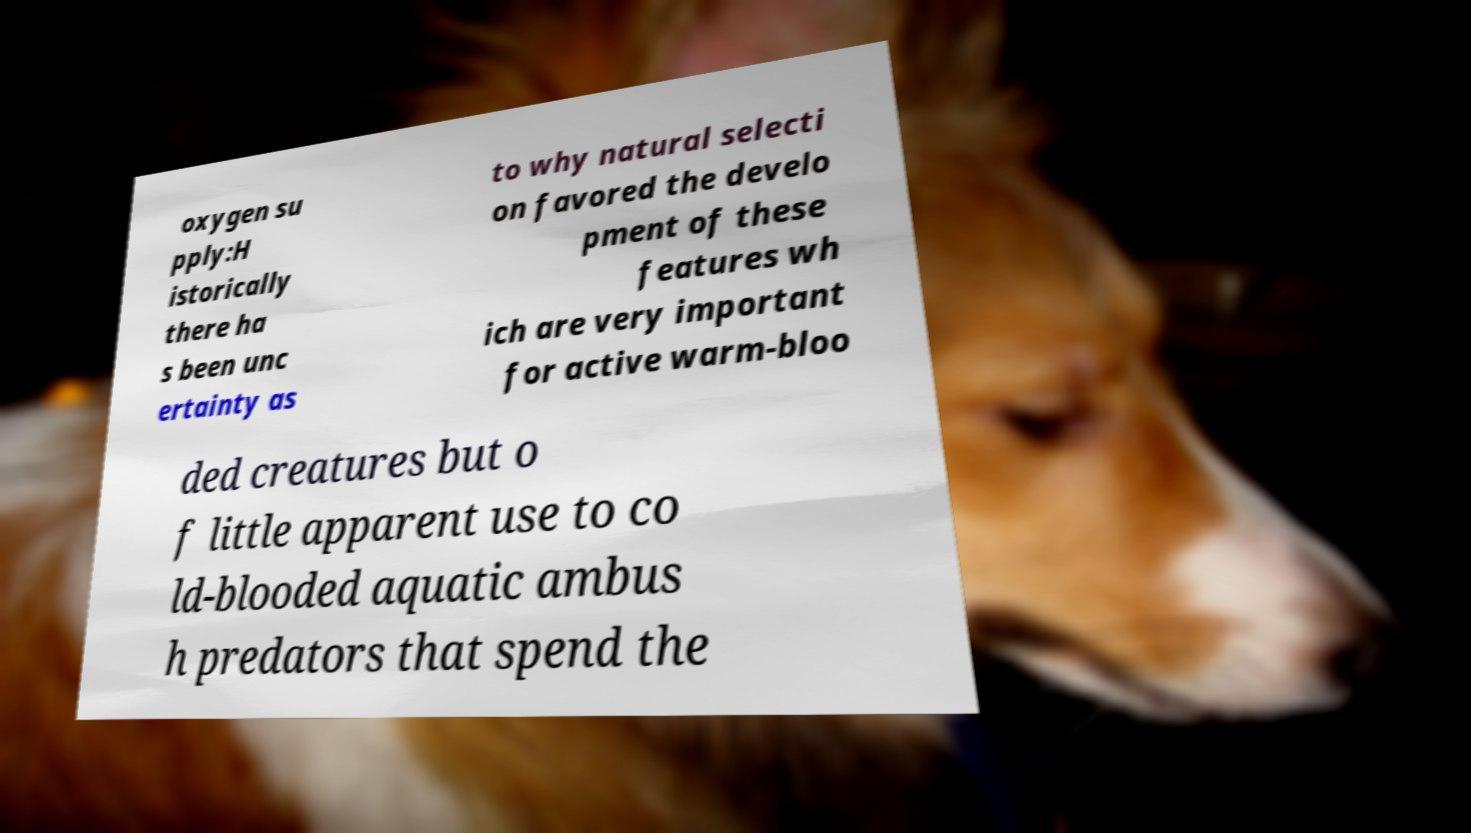What messages or text are displayed in this image? I need them in a readable, typed format. oxygen su pply:H istorically there ha s been unc ertainty as to why natural selecti on favored the develo pment of these features wh ich are very important for active warm-bloo ded creatures but o f little apparent use to co ld-blooded aquatic ambus h predators that spend the 